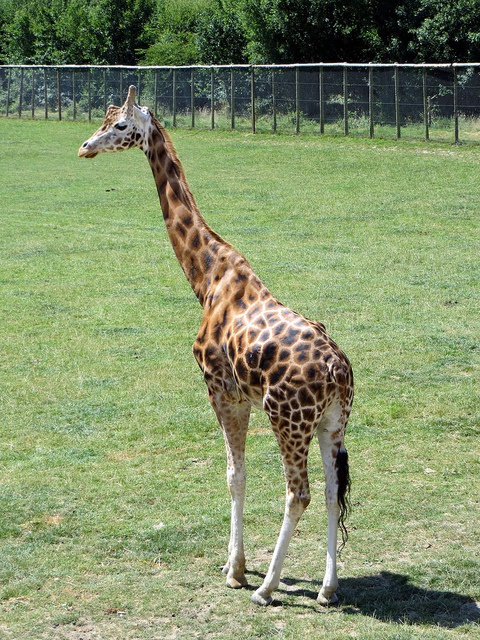Describe the objects in this image and their specific colors. I can see a giraffe in green, gray, black, tan, and darkgray tones in this image. 